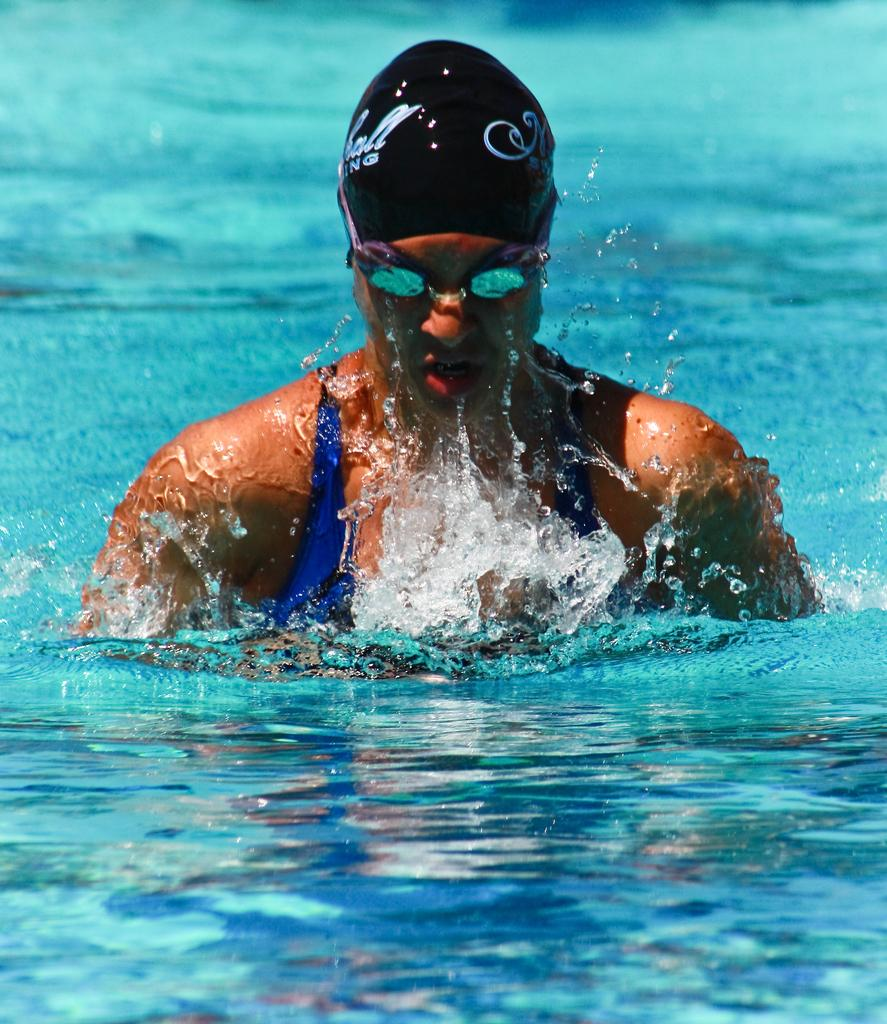What is the person in the water doing? The facts do not specify what the person is doing in the water. What can be seen on the person's head? The person is wearing a cap. What can be seen on the person's face? The person is wearing glasses. What type of clothing is the person wearing? The person is wearing a swimsuit. What type of honey is being used to print the son's name on the swimsuit? There is no honey or printing of names on the swimsuit in the image. 